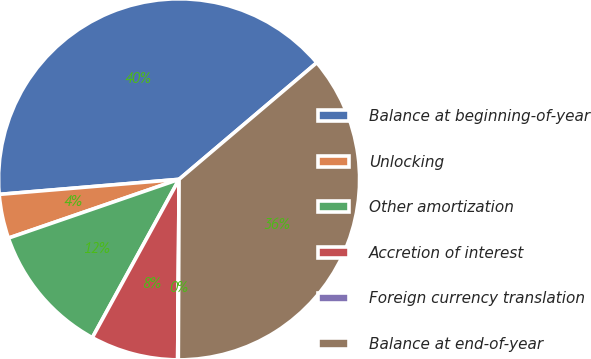Convert chart to OTSL. <chart><loc_0><loc_0><loc_500><loc_500><pie_chart><fcel>Balance at beginning-of-year<fcel>Unlocking<fcel>Other amortization<fcel>Accretion of interest<fcel>Foreign currency translation<fcel>Balance at end-of-year<nl><fcel>40.14%<fcel>3.95%<fcel>11.74%<fcel>7.85%<fcel>0.06%<fcel>36.25%<nl></chart> 